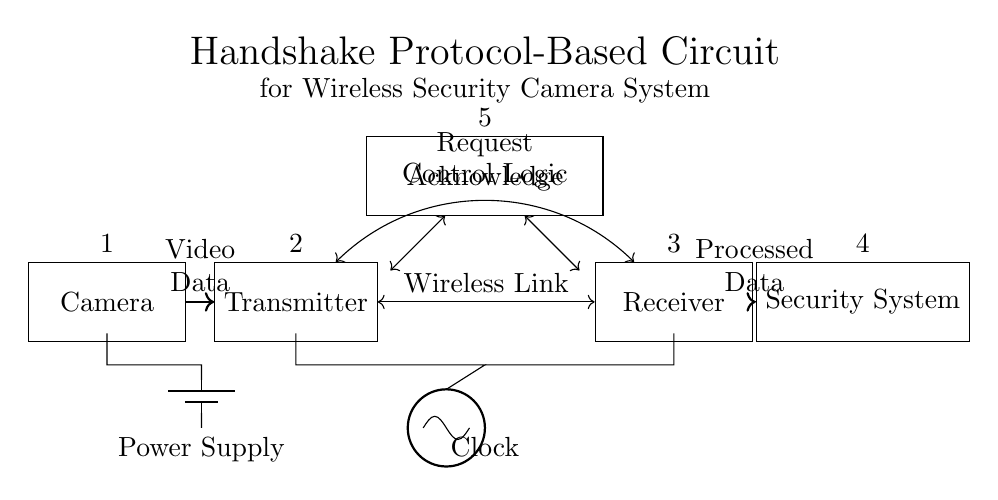What is the power supply component in this circuit? The power supply is represented by a battery symbol, typically found at the bottom left corner of the diagram, indicating where the circuit receives energy.
Answer: Battery What connects the camera to the transmitter? The connection is depicted by a solid line with an arrow indicating the direction of video data flow from the camera to the transmitter node.
Answer: Video Data What type of data is transmitted wirelessly? The wireless link is denoted by a bidirectional arrow between the transmitter and receiver labeled "Request Acknowledge," indicating the kind of communication taking place.
Answer: Request Acknowledge How many main components are in the circuit? The main components are: Camera, Transmitter, Receiver, Security System, and Control Logic, adding up to a total of five distinct parts in the circuit.
Answer: Five What is the role of the clock in this circuit? The clock is shown as an oscillator and is crucial for synchronizing the operations of the transmitter and receiver, ensuring that data exchange occurs at the right intervals.
Answer: Synchronization How many data flows are illustrated in the diagram? The diagram illustrates two data flows: one from the camera to the transmitter (video data) and another from the receiver to the security system (processed data), totaling two distinct flows.
Answer: Two What function does the Control Logic serve in this circuit? The Control Logic, positioned above the transmitter and receiver, coordinates the communication and processing of data between these components, facilitating the entire handshake protocol.
Answer: Coordination 